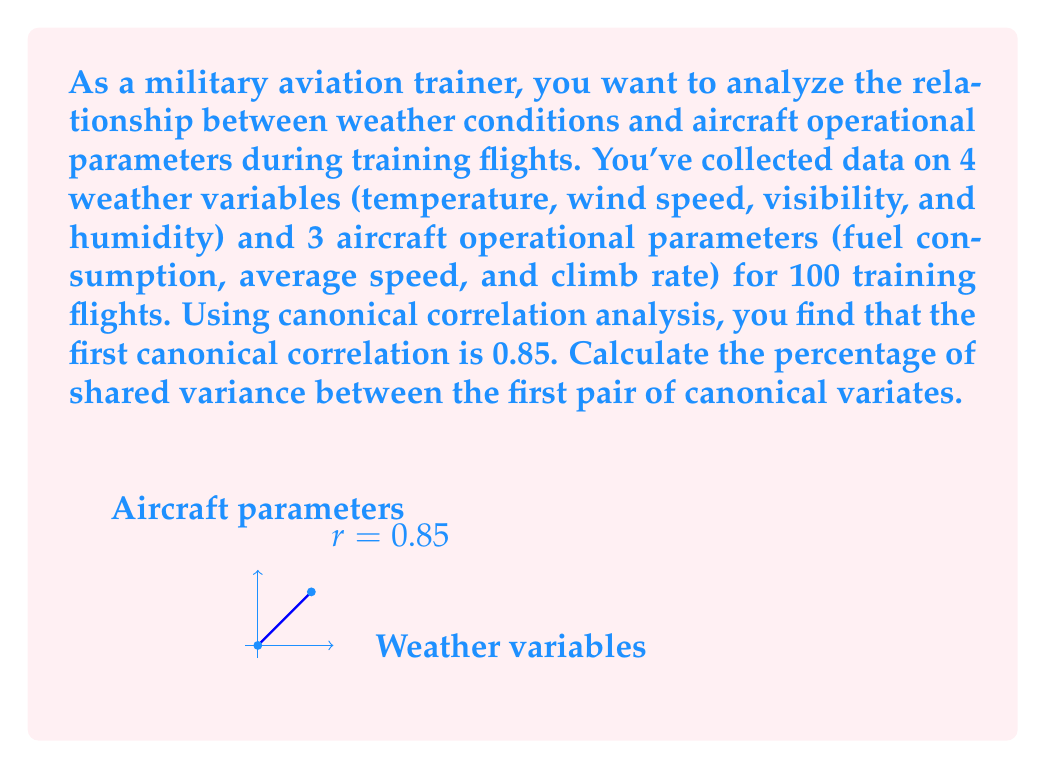Help me with this question. To solve this problem, we'll follow these steps:

1) In canonical correlation analysis, the squared canonical correlation represents the amount of shared variance between the canonical variates.

2) The first canonical correlation is given as 0.85.

3) To find the shared variance, we need to square this correlation:

   $$r^2 = (0.85)^2 = 0.7225$$

4) To express this as a percentage, we multiply by 100:

   $$0.7225 \times 100 = 72.25\%$$

This means that 72.25% of the variance in the first pair of canonical variates is shared between the weather variables and the aircraft operational parameters.

5) Interpretation: This high percentage indicates a strong relationship between the weather conditions and aircraft performance. As a military aviation trainer, this information could be crucial for preparing recruits to anticipate how weather changes might affect their aircraft's behavior during flights.
Answer: 72.25% 